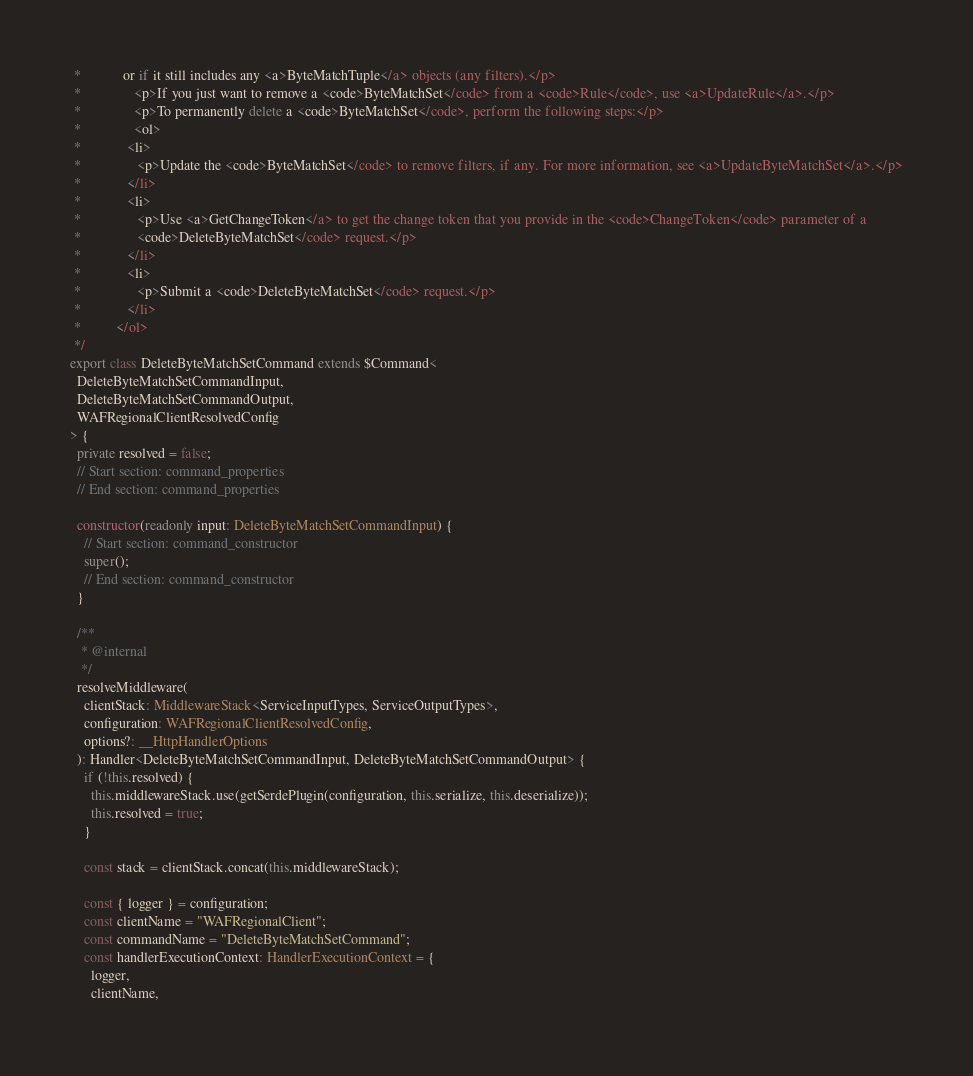<code> <loc_0><loc_0><loc_500><loc_500><_TypeScript_> * 			or if it still includes any <a>ByteMatchTuple</a> objects (any filters).</p>
 * 		       <p>If you just want to remove a <code>ByteMatchSet</code> from a <code>Rule</code>, use <a>UpdateRule</a>.</p>
 * 		       <p>To permanently delete a <code>ByteMatchSet</code>, perform the following steps:</p>
 * 		       <ol>
 *             <li>
 *                <p>Update the <code>ByteMatchSet</code> to remove filters, if any. For more information, see <a>UpdateByteMatchSet</a>.</p>
 *             </li>
 *             <li>
 *                <p>Use <a>GetChangeToken</a> to get the change token that you provide in the <code>ChangeToken</code> parameter of a
 * 				<code>DeleteByteMatchSet</code> request.</p>
 *             </li>
 *             <li>
 *                <p>Submit a <code>DeleteByteMatchSet</code> request.</p>
 *             </li>
 *          </ol>
 */
export class DeleteByteMatchSetCommand extends $Command<
  DeleteByteMatchSetCommandInput,
  DeleteByteMatchSetCommandOutput,
  WAFRegionalClientResolvedConfig
> {
  private resolved = false;
  // Start section: command_properties
  // End section: command_properties

  constructor(readonly input: DeleteByteMatchSetCommandInput) {
    // Start section: command_constructor
    super();
    // End section: command_constructor
  }

  /**
   * @internal
   */
  resolveMiddleware(
    clientStack: MiddlewareStack<ServiceInputTypes, ServiceOutputTypes>,
    configuration: WAFRegionalClientResolvedConfig,
    options?: __HttpHandlerOptions
  ): Handler<DeleteByteMatchSetCommandInput, DeleteByteMatchSetCommandOutput> {
    if (!this.resolved) {
      this.middlewareStack.use(getSerdePlugin(configuration, this.serialize, this.deserialize));
      this.resolved = true;
    }

    const stack = clientStack.concat(this.middlewareStack);

    const { logger } = configuration;
    const clientName = "WAFRegionalClient";
    const commandName = "DeleteByteMatchSetCommand";
    const handlerExecutionContext: HandlerExecutionContext = {
      logger,
      clientName,</code> 